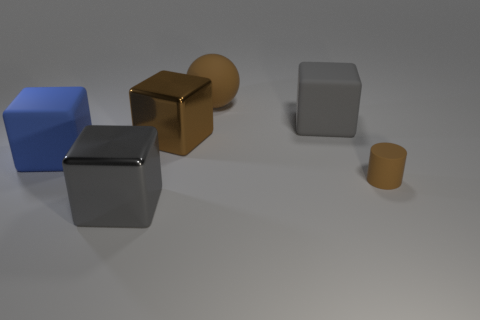Subtract 1 cubes. How many cubes are left? 3 Subtract all cyan blocks. Subtract all brown cylinders. How many blocks are left? 4 Add 1 gray cubes. How many objects exist? 7 Subtract all blocks. How many objects are left? 2 Subtract all gray rubber blocks. Subtract all large objects. How many objects are left? 0 Add 4 brown matte cylinders. How many brown matte cylinders are left? 5 Add 5 tiny purple metallic objects. How many tiny purple metallic objects exist? 5 Subtract 0 yellow spheres. How many objects are left? 6 